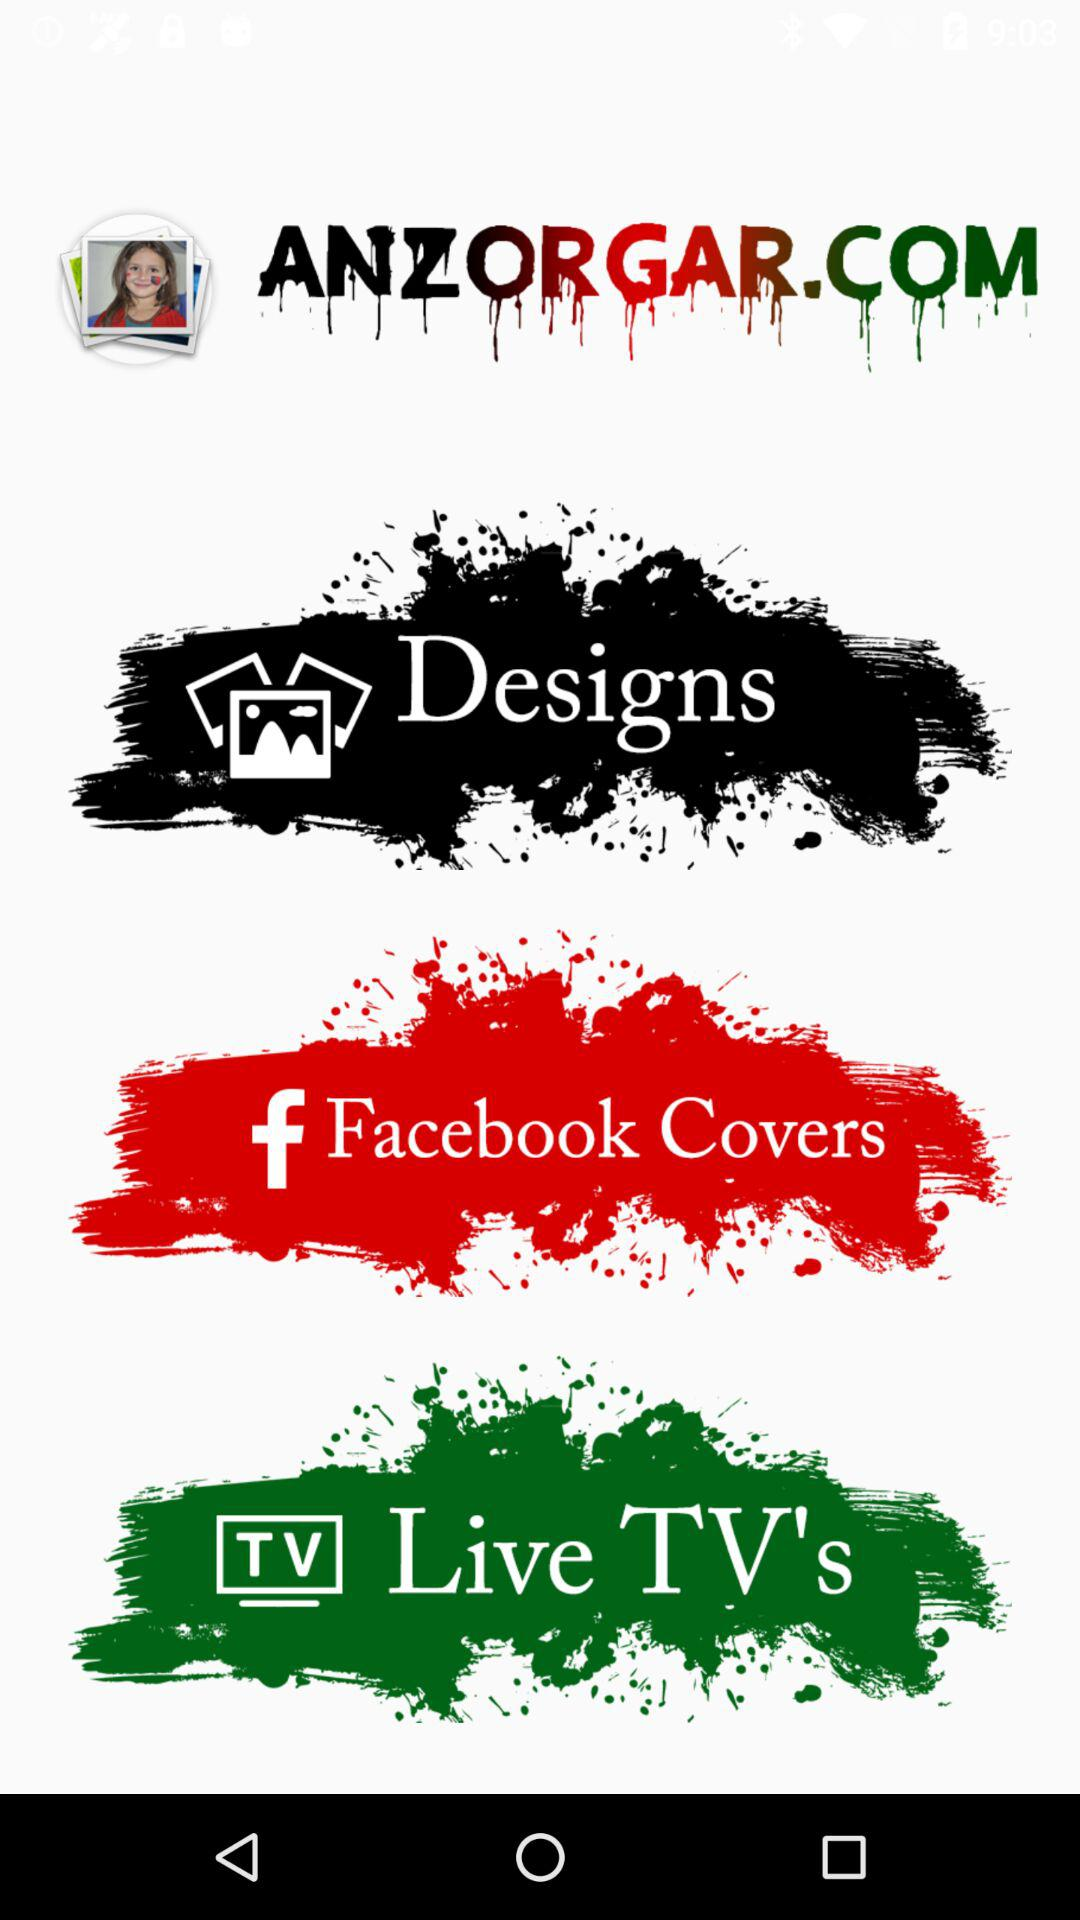Which live TV channels are available?
When the provided information is insufficient, respond with <no answer>. <no answer> 